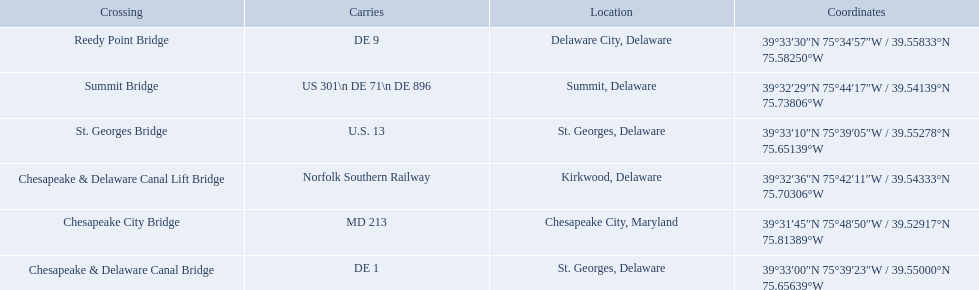What is being carried in the canal? MD 213, US 301\n DE 71\n DE 896, Norfolk Southern Railway, DE 1, U.S. 13, DE 9. Of those which has the largest number of different routes? US 301\n DE 71\n DE 896. Parse the table in full. {'header': ['Crossing', 'Carries', 'Location', 'Coordinates'], 'rows': [['Reedy Point Bridge', 'DE\xa09', 'Delaware City, Delaware', '39°33′30″N 75°34′57″W\ufeff / \ufeff39.55833°N 75.58250°W'], ['Summit Bridge', 'US 301\\n DE 71\\n DE 896', 'Summit, Delaware', '39°32′29″N 75°44′17″W\ufeff / \ufeff39.54139°N 75.73806°W'], ['St.\xa0Georges Bridge', 'U.S.\xa013', 'St.\xa0Georges, Delaware', '39°33′10″N 75°39′05″W\ufeff / \ufeff39.55278°N 75.65139°W'], ['Chesapeake & Delaware Canal Lift Bridge', 'Norfolk Southern Railway', 'Kirkwood, Delaware', '39°32′36″N 75°42′11″W\ufeff / \ufeff39.54333°N 75.70306°W'], ['Chesapeake City Bridge', 'MD 213', 'Chesapeake City, Maryland', '39°31′45″N 75°48′50″W\ufeff / \ufeff39.52917°N 75.81389°W'], ['Chesapeake & Delaware Canal Bridge', 'DE 1', 'St.\xa0Georges, Delaware', '39°33′00″N 75°39′23″W\ufeff / \ufeff39.55000°N 75.65639°W']]} To which crossing does that relate? Summit Bridge. 